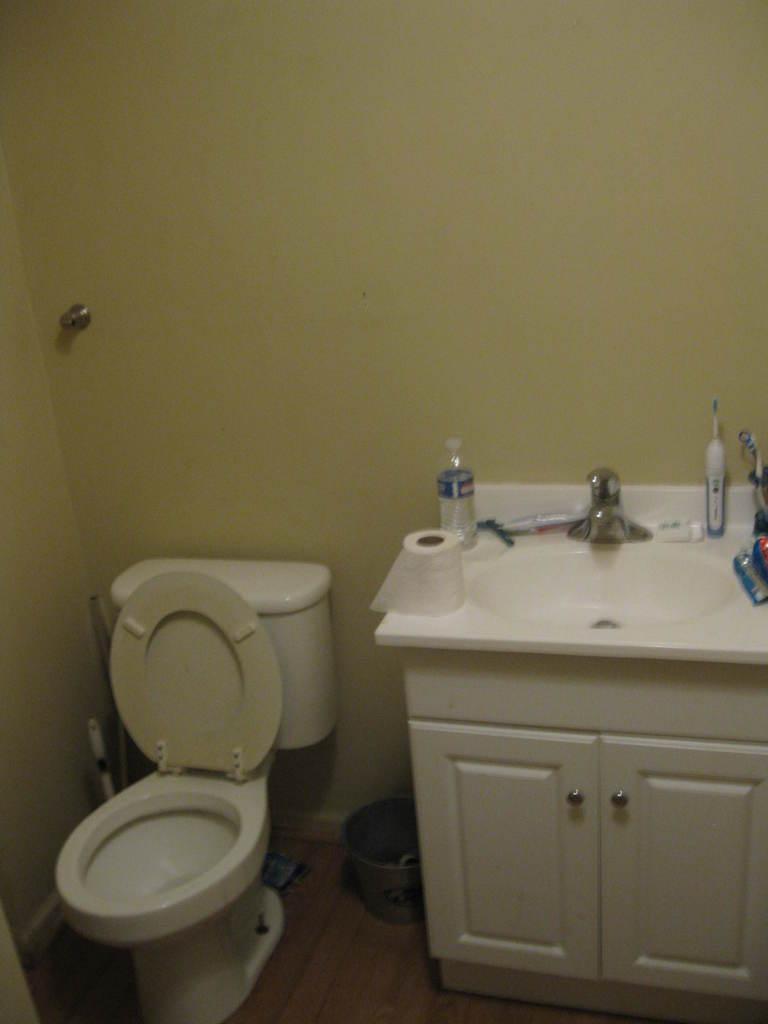In one or two sentences, can you explain what this image depicts? This is the picture of a room. On the left side of the image there is a toilet seat and there is a bucket. On the right side of the image there is a wash basin and there is a bottle, tissues roller and other objects on the washbasin. At the bottom there is a cupboard. At the back there is a tap on the wall. 